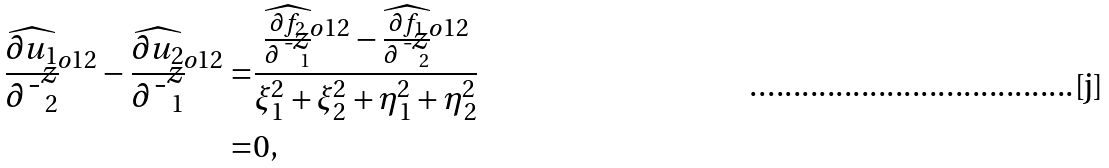<formula> <loc_0><loc_0><loc_500><loc_500>\widehat { \frac { \partial u _ { 1 } } { \partial \bar { z } _ { 2 } } } ^ { o 1 2 } - \widehat { \frac { \partial u _ { 2 } } { \partial \bar { z } _ { 1 } } } ^ { o 1 2 } = & \frac { \widehat { \frac { \partial f _ { 2 } } { \partial \bar { z } _ { 1 } } } ^ { o 1 2 } - \widehat { \frac { \partial f _ { 1 } } { \partial \bar { z } _ { 2 } } } ^ { o 1 2 } } { \xi _ { 1 } ^ { 2 } + \xi _ { 2 } ^ { 2 } + \eta _ { 1 } ^ { 2 } + \eta _ { 2 } ^ { 2 } } \\ = & 0 ,</formula> 